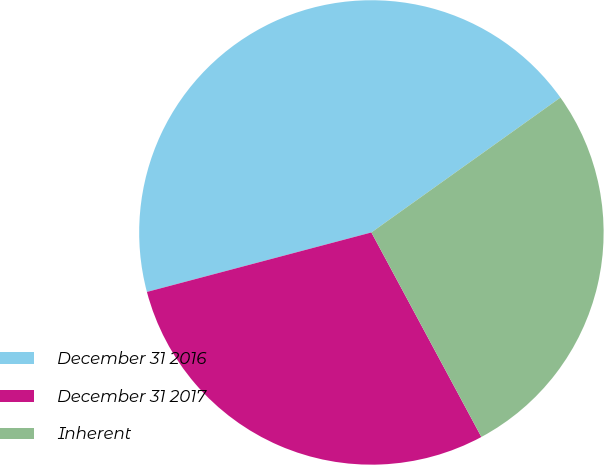Convert chart. <chart><loc_0><loc_0><loc_500><loc_500><pie_chart><fcel>December 31 2016<fcel>December 31 2017<fcel>Inherent<nl><fcel>44.26%<fcel>28.73%<fcel>27.01%<nl></chart> 